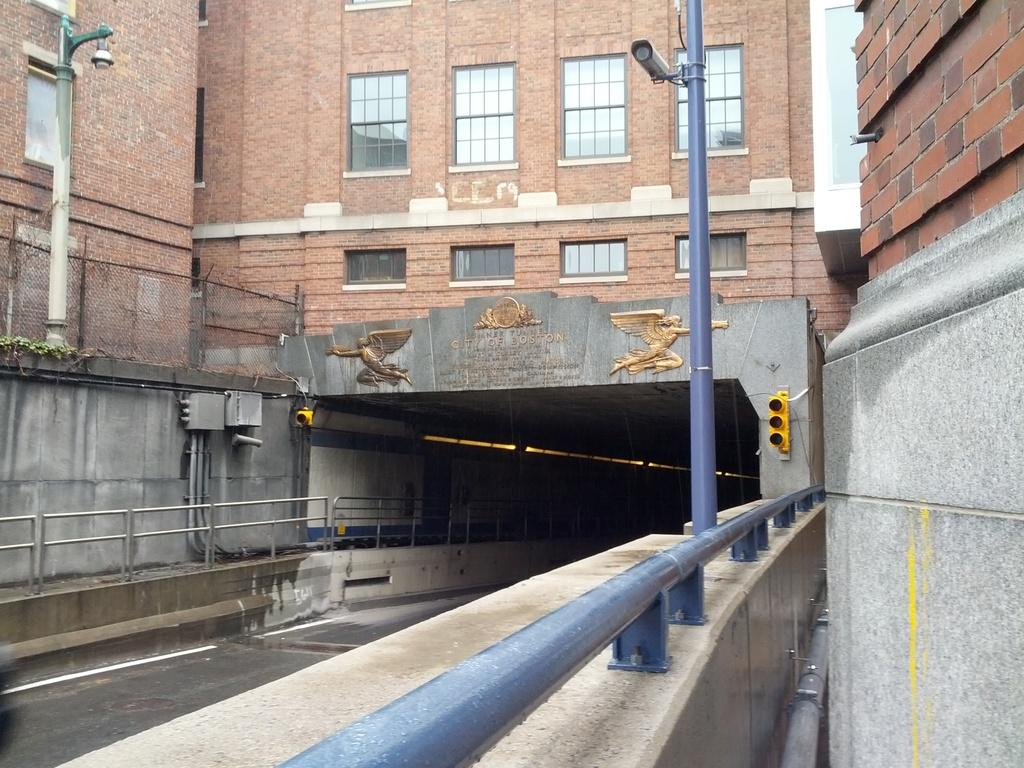What is the main structure in the image? There is a tunnel in the image. What can be seen near the tunnel? There is railing and poles on both sides of the tunnel. What is visible in the background of the image? There is a building with windows in the background of the image. Where is the mom in the image? There is no mom present in the image. What type of machine can be seen operating inside the tunnel? There is no machine visible in the image; it only shows the tunnel, railing, poles, and the building in the background. 